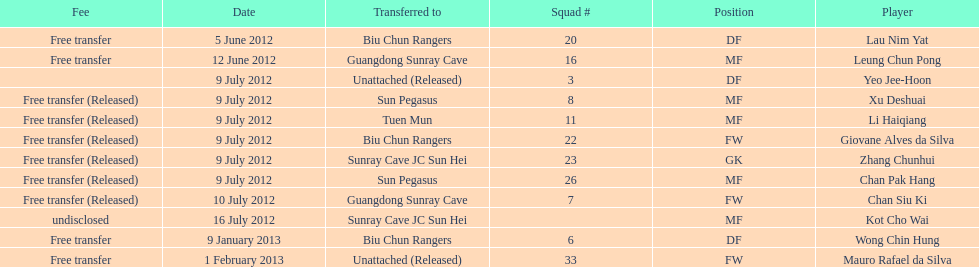Wong chin hung was transferred to his new team on what date? 9 January 2013. 